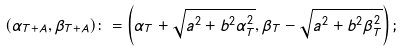<formula> <loc_0><loc_0><loc_500><loc_500>( \alpha _ { T + A } , \beta _ { T + A } ) \colon = \left ( \alpha _ { T } + \sqrt { a ^ { 2 } + b ^ { 2 } \alpha _ { T } ^ { 2 } } , \beta _ { T } - \sqrt { a ^ { 2 } + b ^ { 2 } \beta _ { T } ^ { 2 } } \right ) ;</formula> 